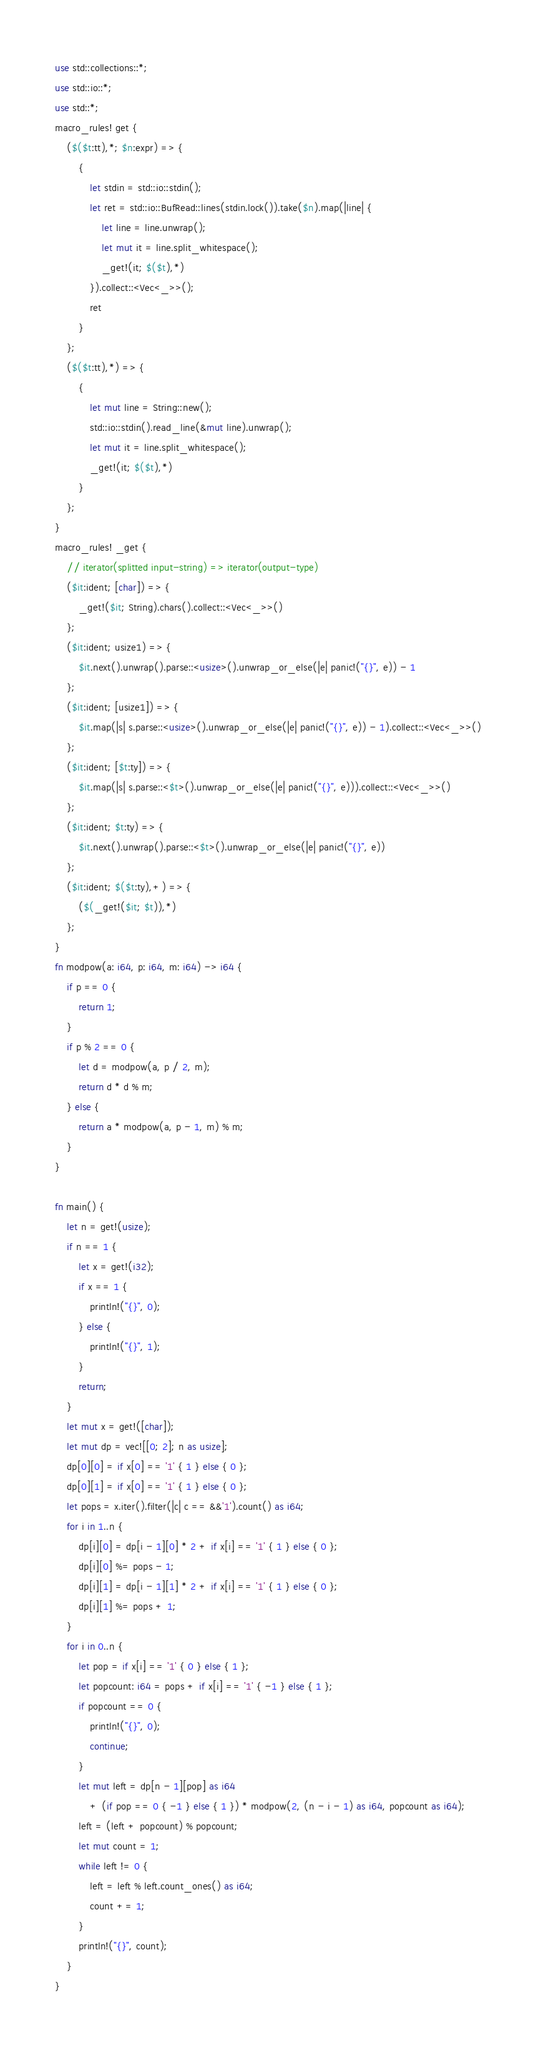<code> <loc_0><loc_0><loc_500><loc_500><_Rust_>use std::collections::*;
use std::io::*;
use std::*;
macro_rules! get {
    ($($t:tt),*; $n:expr) => {
        {
            let stdin = std::io::stdin();
            let ret = std::io::BufRead::lines(stdin.lock()).take($n).map(|line| {
                let line = line.unwrap();
                let mut it = line.split_whitespace();
                _get!(it; $($t),*)
            }).collect::<Vec<_>>();
            ret
        }
    };
    ($($t:tt),*) => {
        {
            let mut line = String::new();
            std::io::stdin().read_line(&mut line).unwrap();
            let mut it = line.split_whitespace();
            _get!(it; $($t),*)
        }
    };
}
macro_rules! _get {
    // iterator(splitted input-string) => iterator(output-type)
    ($it:ident; [char]) => {
        _get!($it; String).chars().collect::<Vec<_>>()
    };
    ($it:ident; usize1) => {
        $it.next().unwrap().parse::<usize>().unwrap_or_else(|e| panic!("{}", e)) - 1
    };
    ($it:ident; [usize1]) => {
        $it.map(|s| s.parse::<usize>().unwrap_or_else(|e| panic!("{}", e)) - 1).collect::<Vec<_>>()
    };
    ($it:ident; [$t:ty]) => {
        $it.map(|s| s.parse::<$t>().unwrap_or_else(|e| panic!("{}", e))).collect::<Vec<_>>()
    };
    ($it:ident; $t:ty) => {
        $it.next().unwrap().parse::<$t>().unwrap_or_else(|e| panic!("{}", e))
    };
    ($it:ident; $($t:ty),+) => {
        ($(_get!($it; $t)),*)
    };
}
fn modpow(a: i64, p: i64, m: i64) -> i64 {
    if p == 0 {
        return 1;
    }
    if p % 2 == 0 {
        let d = modpow(a, p / 2, m);
        return d * d % m;
    } else {
        return a * modpow(a, p - 1, m) % m;
    }
}

fn main() {
    let n = get!(usize);
    if n == 1 {
        let x = get!(i32);
        if x == 1 {
            println!("{}", 0);
        } else {
            println!("{}", 1);
        }
        return;
    }
    let mut x = get!([char]);
    let mut dp = vec![[0; 2]; n as usize];
    dp[0][0] = if x[0] == '1' { 1 } else { 0 };
    dp[0][1] = if x[0] == '1' { 1 } else { 0 };
    let pops = x.iter().filter(|c| c == &&'1').count() as i64;
    for i in 1..n {
        dp[i][0] = dp[i - 1][0] * 2 + if x[i] == '1' { 1 } else { 0 };
        dp[i][0] %= pops - 1;
        dp[i][1] = dp[i - 1][1] * 2 + if x[i] == '1' { 1 } else { 0 };
        dp[i][1] %= pops + 1;
    }
    for i in 0..n {
        let pop = if x[i] == '1' { 0 } else { 1 };
        let popcount: i64 = pops + if x[i] == '1' { -1 } else { 1 };
        if popcount == 0 {
            println!("{}", 0);
            continue;
        }
        let mut left = dp[n - 1][pop] as i64
            + (if pop == 0 { -1 } else { 1 }) * modpow(2, (n - i - 1) as i64, popcount as i64);
        left = (left + popcount) % popcount;
        let mut count = 1;
        while left != 0 {
            left = left % left.count_ones() as i64;
            count += 1;
        }
        println!("{}", count);
    }
}
</code> 